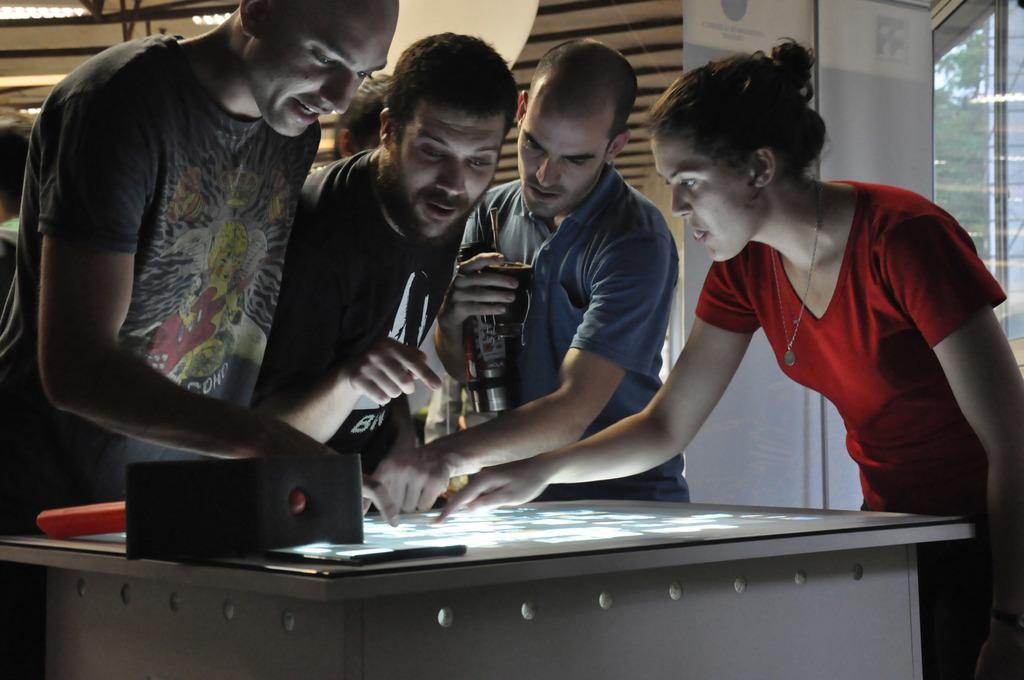How many individuals are present in the image? There is a group of people in the image, but the exact number cannot be determined without more information. Can you describe the group of people in the image? Unfortunately, the provided facts do not give any details about the group of people, so it is impossible to describe them. What type of cave can be seen in the background of the image? There is no cave present in the image; it only features a group of people. How many toes are visible on the people in the image? The number of toes visible on the people in the image cannot be determined without more information about their appearance or footwear. 